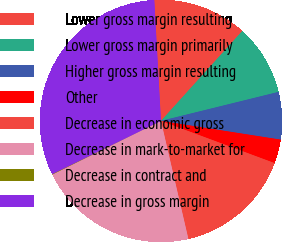<chart> <loc_0><loc_0><loc_500><loc_500><pie_chart><fcel>Lower gross margin resulting<fcel>Lower gross margin primarily<fcel>Higher gross margin resulting<fcel>Other<fcel>Decrease in economic gross<fcel>Decrease in mark-to-market for<fcel>Decrease in contract and<fcel>Decrease in gross margin<nl><fcel>12.58%<fcel>9.45%<fcel>6.32%<fcel>3.19%<fcel>15.71%<fcel>21.34%<fcel>0.06%<fcel>31.36%<nl></chart> 